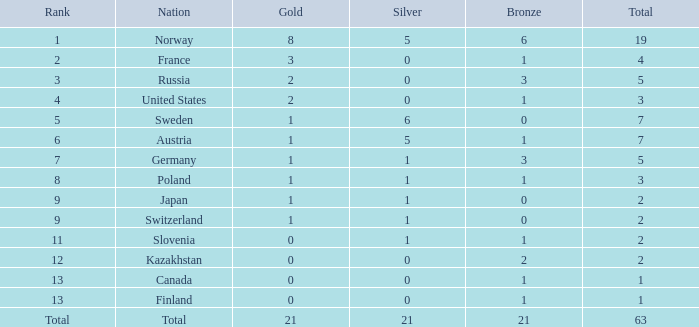What rank contains a gold under 1, and a silver more than 0? 11.0. 